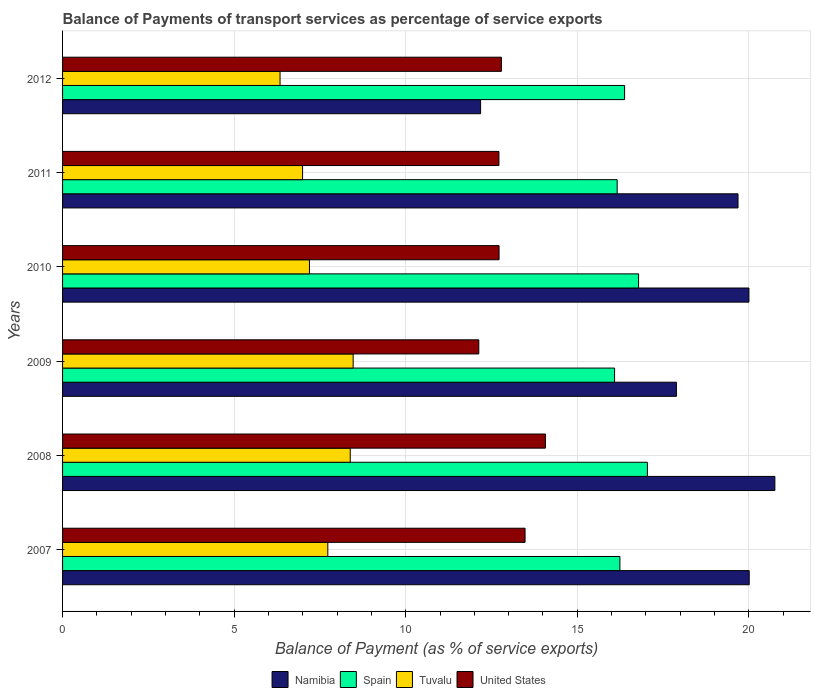Are the number of bars per tick equal to the number of legend labels?
Your response must be concise. Yes. What is the label of the 6th group of bars from the top?
Provide a succinct answer. 2007. What is the balance of payments of transport services in Namibia in 2010?
Give a very brief answer. 20. Across all years, what is the maximum balance of payments of transport services in Namibia?
Your answer should be compact. 20.76. Across all years, what is the minimum balance of payments of transport services in Spain?
Your answer should be compact. 16.09. In which year was the balance of payments of transport services in Spain maximum?
Ensure brevity in your answer.  2008. In which year was the balance of payments of transport services in United States minimum?
Ensure brevity in your answer.  2009. What is the total balance of payments of transport services in Spain in the graph?
Make the answer very short. 98.7. What is the difference between the balance of payments of transport services in Tuvalu in 2010 and that in 2011?
Your response must be concise. 0.2. What is the difference between the balance of payments of transport services in Spain in 2010 and the balance of payments of transport services in United States in 2012?
Your response must be concise. 4. What is the average balance of payments of transport services in Namibia per year?
Keep it short and to the point. 18.42. In the year 2007, what is the difference between the balance of payments of transport services in United States and balance of payments of transport services in Spain?
Your response must be concise. -2.76. In how many years, is the balance of payments of transport services in Spain greater than 4 %?
Offer a terse response. 6. What is the ratio of the balance of payments of transport services in Spain in 2010 to that in 2012?
Provide a short and direct response. 1.02. What is the difference between the highest and the second highest balance of payments of transport services in Namibia?
Ensure brevity in your answer.  0.75. What is the difference between the highest and the lowest balance of payments of transport services in Spain?
Your answer should be very brief. 0.96. In how many years, is the balance of payments of transport services in Tuvalu greater than the average balance of payments of transport services in Tuvalu taken over all years?
Your response must be concise. 3. Is it the case that in every year, the sum of the balance of payments of transport services in United States and balance of payments of transport services in Tuvalu is greater than the sum of balance of payments of transport services in Spain and balance of payments of transport services in Namibia?
Make the answer very short. No. What does the 2nd bar from the bottom in 2010 represents?
Offer a very short reply. Spain. Is it the case that in every year, the sum of the balance of payments of transport services in Tuvalu and balance of payments of transport services in Spain is greater than the balance of payments of transport services in Namibia?
Give a very brief answer. Yes. How many bars are there?
Offer a very short reply. 24. How many years are there in the graph?
Offer a very short reply. 6. Are the values on the major ticks of X-axis written in scientific E-notation?
Your response must be concise. No. Does the graph contain any zero values?
Your answer should be compact. No. Where does the legend appear in the graph?
Offer a very short reply. Bottom center. How many legend labels are there?
Ensure brevity in your answer.  4. How are the legend labels stacked?
Ensure brevity in your answer.  Horizontal. What is the title of the graph?
Provide a short and direct response. Balance of Payments of transport services as percentage of service exports. Does "Vanuatu" appear as one of the legend labels in the graph?
Give a very brief answer. No. What is the label or title of the X-axis?
Keep it short and to the point. Balance of Payment (as % of service exports). What is the Balance of Payment (as % of service exports) in Namibia in 2007?
Provide a succinct answer. 20.01. What is the Balance of Payment (as % of service exports) in Spain in 2007?
Give a very brief answer. 16.24. What is the Balance of Payment (as % of service exports) in Tuvalu in 2007?
Offer a very short reply. 7.73. What is the Balance of Payment (as % of service exports) in United States in 2007?
Your response must be concise. 13.48. What is the Balance of Payment (as % of service exports) of Namibia in 2008?
Give a very brief answer. 20.76. What is the Balance of Payment (as % of service exports) in Spain in 2008?
Ensure brevity in your answer.  17.04. What is the Balance of Payment (as % of service exports) of Tuvalu in 2008?
Keep it short and to the point. 8.38. What is the Balance of Payment (as % of service exports) of United States in 2008?
Offer a terse response. 14.07. What is the Balance of Payment (as % of service exports) in Namibia in 2009?
Your response must be concise. 17.89. What is the Balance of Payment (as % of service exports) of Spain in 2009?
Your answer should be very brief. 16.09. What is the Balance of Payment (as % of service exports) of Tuvalu in 2009?
Keep it short and to the point. 8.47. What is the Balance of Payment (as % of service exports) in United States in 2009?
Your response must be concise. 12.13. What is the Balance of Payment (as % of service exports) in Namibia in 2010?
Your answer should be very brief. 20. What is the Balance of Payment (as % of service exports) of Spain in 2010?
Your response must be concise. 16.79. What is the Balance of Payment (as % of service exports) in Tuvalu in 2010?
Your answer should be compact. 7.19. What is the Balance of Payment (as % of service exports) of United States in 2010?
Provide a short and direct response. 12.72. What is the Balance of Payment (as % of service exports) of Namibia in 2011?
Offer a terse response. 19.68. What is the Balance of Payment (as % of service exports) of Spain in 2011?
Provide a short and direct response. 16.16. What is the Balance of Payment (as % of service exports) of Tuvalu in 2011?
Give a very brief answer. 6.99. What is the Balance of Payment (as % of service exports) of United States in 2011?
Your answer should be compact. 12.72. What is the Balance of Payment (as % of service exports) in Namibia in 2012?
Provide a succinct answer. 12.18. What is the Balance of Payment (as % of service exports) of Spain in 2012?
Your answer should be compact. 16.38. What is the Balance of Payment (as % of service exports) of Tuvalu in 2012?
Provide a short and direct response. 6.34. What is the Balance of Payment (as % of service exports) of United States in 2012?
Your response must be concise. 12.79. Across all years, what is the maximum Balance of Payment (as % of service exports) of Namibia?
Your answer should be compact. 20.76. Across all years, what is the maximum Balance of Payment (as % of service exports) in Spain?
Your response must be concise. 17.04. Across all years, what is the maximum Balance of Payment (as % of service exports) of Tuvalu?
Make the answer very short. 8.47. Across all years, what is the maximum Balance of Payment (as % of service exports) of United States?
Ensure brevity in your answer.  14.07. Across all years, what is the minimum Balance of Payment (as % of service exports) in Namibia?
Your answer should be compact. 12.18. Across all years, what is the minimum Balance of Payment (as % of service exports) of Spain?
Give a very brief answer. 16.09. Across all years, what is the minimum Balance of Payment (as % of service exports) of Tuvalu?
Your answer should be very brief. 6.34. Across all years, what is the minimum Balance of Payment (as % of service exports) in United States?
Your response must be concise. 12.13. What is the total Balance of Payment (as % of service exports) of Namibia in the graph?
Keep it short and to the point. 110.52. What is the total Balance of Payment (as % of service exports) of Spain in the graph?
Give a very brief answer. 98.7. What is the total Balance of Payment (as % of service exports) in Tuvalu in the graph?
Provide a short and direct response. 45.11. What is the total Balance of Payment (as % of service exports) in United States in the graph?
Ensure brevity in your answer.  77.9. What is the difference between the Balance of Payment (as % of service exports) of Namibia in 2007 and that in 2008?
Provide a succinct answer. -0.75. What is the difference between the Balance of Payment (as % of service exports) of Spain in 2007 and that in 2008?
Provide a short and direct response. -0.8. What is the difference between the Balance of Payment (as % of service exports) in Tuvalu in 2007 and that in 2008?
Offer a very short reply. -0.65. What is the difference between the Balance of Payment (as % of service exports) in United States in 2007 and that in 2008?
Ensure brevity in your answer.  -0.59. What is the difference between the Balance of Payment (as % of service exports) of Namibia in 2007 and that in 2009?
Provide a short and direct response. 2.12. What is the difference between the Balance of Payment (as % of service exports) in Spain in 2007 and that in 2009?
Provide a succinct answer. 0.16. What is the difference between the Balance of Payment (as % of service exports) in Tuvalu in 2007 and that in 2009?
Make the answer very short. -0.74. What is the difference between the Balance of Payment (as % of service exports) in United States in 2007 and that in 2009?
Make the answer very short. 1.35. What is the difference between the Balance of Payment (as % of service exports) of Namibia in 2007 and that in 2010?
Provide a succinct answer. 0.01. What is the difference between the Balance of Payment (as % of service exports) of Spain in 2007 and that in 2010?
Offer a terse response. -0.54. What is the difference between the Balance of Payment (as % of service exports) of Tuvalu in 2007 and that in 2010?
Offer a very short reply. 0.54. What is the difference between the Balance of Payment (as % of service exports) of United States in 2007 and that in 2010?
Make the answer very short. 0.76. What is the difference between the Balance of Payment (as % of service exports) of Namibia in 2007 and that in 2011?
Keep it short and to the point. 0.33. What is the difference between the Balance of Payment (as % of service exports) of Spain in 2007 and that in 2011?
Your answer should be very brief. 0.08. What is the difference between the Balance of Payment (as % of service exports) of Tuvalu in 2007 and that in 2011?
Your response must be concise. 0.73. What is the difference between the Balance of Payment (as % of service exports) in United States in 2007 and that in 2011?
Your answer should be compact. 0.76. What is the difference between the Balance of Payment (as % of service exports) of Namibia in 2007 and that in 2012?
Your response must be concise. 7.83. What is the difference between the Balance of Payment (as % of service exports) in Spain in 2007 and that in 2012?
Keep it short and to the point. -0.14. What is the difference between the Balance of Payment (as % of service exports) of Tuvalu in 2007 and that in 2012?
Ensure brevity in your answer.  1.39. What is the difference between the Balance of Payment (as % of service exports) of United States in 2007 and that in 2012?
Provide a succinct answer. 0.69. What is the difference between the Balance of Payment (as % of service exports) in Namibia in 2008 and that in 2009?
Provide a succinct answer. 2.87. What is the difference between the Balance of Payment (as % of service exports) in Spain in 2008 and that in 2009?
Provide a succinct answer. 0.96. What is the difference between the Balance of Payment (as % of service exports) in Tuvalu in 2008 and that in 2009?
Your answer should be very brief. -0.09. What is the difference between the Balance of Payment (as % of service exports) in United States in 2008 and that in 2009?
Offer a terse response. 1.94. What is the difference between the Balance of Payment (as % of service exports) in Namibia in 2008 and that in 2010?
Ensure brevity in your answer.  0.76. What is the difference between the Balance of Payment (as % of service exports) of Spain in 2008 and that in 2010?
Offer a very short reply. 0.26. What is the difference between the Balance of Payment (as % of service exports) of Tuvalu in 2008 and that in 2010?
Provide a short and direct response. 1.19. What is the difference between the Balance of Payment (as % of service exports) of United States in 2008 and that in 2010?
Offer a terse response. 1.35. What is the difference between the Balance of Payment (as % of service exports) in Namibia in 2008 and that in 2011?
Offer a very short reply. 1.07. What is the difference between the Balance of Payment (as % of service exports) in Spain in 2008 and that in 2011?
Make the answer very short. 0.88. What is the difference between the Balance of Payment (as % of service exports) of Tuvalu in 2008 and that in 2011?
Offer a very short reply. 1.39. What is the difference between the Balance of Payment (as % of service exports) of United States in 2008 and that in 2011?
Offer a very short reply. 1.35. What is the difference between the Balance of Payment (as % of service exports) in Namibia in 2008 and that in 2012?
Keep it short and to the point. 8.58. What is the difference between the Balance of Payment (as % of service exports) in Spain in 2008 and that in 2012?
Your answer should be very brief. 0.66. What is the difference between the Balance of Payment (as % of service exports) in Tuvalu in 2008 and that in 2012?
Make the answer very short. 2.05. What is the difference between the Balance of Payment (as % of service exports) in United States in 2008 and that in 2012?
Ensure brevity in your answer.  1.28. What is the difference between the Balance of Payment (as % of service exports) in Namibia in 2009 and that in 2010?
Your response must be concise. -2.11. What is the difference between the Balance of Payment (as % of service exports) in Spain in 2009 and that in 2010?
Provide a short and direct response. -0.7. What is the difference between the Balance of Payment (as % of service exports) in Tuvalu in 2009 and that in 2010?
Keep it short and to the point. 1.27. What is the difference between the Balance of Payment (as % of service exports) in United States in 2009 and that in 2010?
Give a very brief answer. -0.59. What is the difference between the Balance of Payment (as % of service exports) in Namibia in 2009 and that in 2011?
Provide a succinct answer. -1.79. What is the difference between the Balance of Payment (as % of service exports) of Spain in 2009 and that in 2011?
Your answer should be very brief. -0.08. What is the difference between the Balance of Payment (as % of service exports) of Tuvalu in 2009 and that in 2011?
Provide a short and direct response. 1.47. What is the difference between the Balance of Payment (as % of service exports) in United States in 2009 and that in 2011?
Your answer should be very brief. -0.59. What is the difference between the Balance of Payment (as % of service exports) of Namibia in 2009 and that in 2012?
Offer a very short reply. 5.71. What is the difference between the Balance of Payment (as % of service exports) of Spain in 2009 and that in 2012?
Your response must be concise. -0.29. What is the difference between the Balance of Payment (as % of service exports) of Tuvalu in 2009 and that in 2012?
Offer a very short reply. 2.13. What is the difference between the Balance of Payment (as % of service exports) of United States in 2009 and that in 2012?
Give a very brief answer. -0.66. What is the difference between the Balance of Payment (as % of service exports) of Namibia in 2010 and that in 2011?
Your response must be concise. 0.32. What is the difference between the Balance of Payment (as % of service exports) in Spain in 2010 and that in 2011?
Your answer should be very brief. 0.62. What is the difference between the Balance of Payment (as % of service exports) in United States in 2010 and that in 2011?
Keep it short and to the point. 0. What is the difference between the Balance of Payment (as % of service exports) in Namibia in 2010 and that in 2012?
Offer a terse response. 7.82. What is the difference between the Balance of Payment (as % of service exports) of Spain in 2010 and that in 2012?
Your response must be concise. 0.41. What is the difference between the Balance of Payment (as % of service exports) in Tuvalu in 2010 and that in 2012?
Make the answer very short. 0.86. What is the difference between the Balance of Payment (as % of service exports) in United States in 2010 and that in 2012?
Offer a very short reply. -0.07. What is the difference between the Balance of Payment (as % of service exports) of Namibia in 2011 and that in 2012?
Make the answer very short. 7.5. What is the difference between the Balance of Payment (as % of service exports) of Spain in 2011 and that in 2012?
Your answer should be very brief. -0.22. What is the difference between the Balance of Payment (as % of service exports) of Tuvalu in 2011 and that in 2012?
Offer a terse response. 0.66. What is the difference between the Balance of Payment (as % of service exports) in United States in 2011 and that in 2012?
Give a very brief answer. -0.07. What is the difference between the Balance of Payment (as % of service exports) in Namibia in 2007 and the Balance of Payment (as % of service exports) in Spain in 2008?
Provide a succinct answer. 2.97. What is the difference between the Balance of Payment (as % of service exports) in Namibia in 2007 and the Balance of Payment (as % of service exports) in Tuvalu in 2008?
Your answer should be compact. 11.63. What is the difference between the Balance of Payment (as % of service exports) of Namibia in 2007 and the Balance of Payment (as % of service exports) of United States in 2008?
Give a very brief answer. 5.94. What is the difference between the Balance of Payment (as % of service exports) of Spain in 2007 and the Balance of Payment (as % of service exports) of Tuvalu in 2008?
Give a very brief answer. 7.86. What is the difference between the Balance of Payment (as % of service exports) of Spain in 2007 and the Balance of Payment (as % of service exports) of United States in 2008?
Ensure brevity in your answer.  2.17. What is the difference between the Balance of Payment (as % of service exports) of Tuvalu in 2007 and the Balance of Payment (as % of service exports) of United States in 2008?
Your response must be concise. -6.34. What is the difference between the Balance of Payment (as % of service exports) of Namibia in 2007 and the Balance of Payment (as % of service exports) of Spain in 2009?
Your response must be concise. 3.92. What is the difference between the Balance of Payment (as % of service exports) of Namibia in 2007 and the Balance of Payment (as % of service exports) of Tuvalu in 2009?
Your answer should be compact. 11.54. What is the difference between the Balance of Payment (as % of service exports) in Namibia in 2007 and the Balance of Payment (as % of service exports) in United States in 2009?
Ensure brevity in your answer.  7.88. What is the difference between the Balance of Payment (as % of service exports) in Spain in 2007 and the Balance of Payment (as % of service exports) in Tuvalu in 2009?
Give a very brief answer. 7.77. What is the difference between the Balance of Payment (as % of service exports) in Spain in 2007 and the Balance of Payment (as % of service exports) in United States in 2009?
Your answer should be compact. 4.11. What is the difference between the Balance of Payment (as % of service exports) of Namibia in 2007 and the Balance of Payment (as % of service exports) of Spain in 2010?
Provide a succinct answer. 3.22. What is the difference between the Balance of Payment (as % of service exports) of Namibia in 2007 and the Balance of Payment (as % of service exports) of Tuvalu in 2010?
Offer a terse response. 12.82. What is the difference between the Balance of Payment (as % of service exports) of Namibia in 2007 and the Balance of Payment (as % of service exports) of United States in 2010?
Provide a short and direct response. 7.29. What is the difference between the Balance of Payment (as % of service exports) in Spain in 2007 and the Balance of Payment (as % of service exports) in Tuvalu in 2010?
Keep it short and to the point. 9.05. What is the difference between the Balance of Payment (as % of service exports) of Spain in 2007 and the Balance of Payment (as % of service exports) of United States in 2010?
Give a very brief answer. 3.52. What is the difference between the Balance of Payment (as % of service exports) in Tuvalu in 2007 and the Balance of Payment (as % of service exports) in United States in 2010?
Offer a terse response. -4.99. What is the difference between the Balance of Payment (as % of service exports) of Namibia in 2007 and the Balance of Payment (as % of service exports) of Spain in 2011?
Ensure brevity in your answer.  3.85. What is the difference between the Balance of Payment (as % of service exports) in Namibia in 2007 and the Balance of Payment (as % of service exports) in Tuvalu in 2011?
Provide a short and direct response. 13.02. What is the difference between the Balance of Payment (as % of service exports) in Namibia in 2007 and the Balance of Payment (as % of service exports) in United States in 2011?
Your answer should be compact. 7.29. What is the difference between the Balance of Payment (as % of service exports) of Spain in 2007 and the Balance of Payment (as % of service exports) of Tuvalu in 2011?
Make the answer very short. 9.25. What is the difference between the Balance of Payment (as % of service exports) in Spain in 2007 and the Balance of Payment (as % of service exports) in United States in 2011?
Make the answer very short. 3.53. What is the difference between the Balance of Payment (as % of service exports) of Tuvalu in 2007 and the Balance of Payment (as % of service exports) of United States in 2011?
Your response must be concise. -4.99. What is the difference between the Balance of Payment (as % of service exports) of Namibia in 2007 and the Balance of Payment (as % of service exports) of Spain in 2012?
Ensure brevity in your answer.  3.63. What is the difference between the Balance of Payment (as % of service exports) in Namibia in 2007 and the Balance of Payment (as % of service exports) in Tuvalu in 2012?
Your answer should be very brief. 13.67. What is the difference between the Balance of Payment (as % of service exports) in Namibia in 2007 and the Balance of Payment (as % of service exports) in United States in 2012?
Your answer should be compact. 7.22. What is the difference between the Balance of Payment (as % of service exports) in Spain in 2007 and the Balance of Payment (as % of service exports) in Tuvalu in 2012?
Make the answer very short. 9.9. What is the difference between the Balance of Payment (as % of service exports) of Spain in 2007 and the Balance of Payment (as % of service exports) of United States in 2012?
Your answer should be very brief. 3.45. What is the difference between the Balance of Payment (as % of service exports) in Tuvalu in 2007 and the Balance of Payment (as % of service exports) in United States in 2012?
Keep it short and to the point. -5.06. What is the difference between the Balance of Payment (as % of service exports) in Namibia in 2008 and the Balance of Payment (as % of service exports) in Spain in 2009?
Ensure brevity in your answer.  4.67. What is the difference between the Balance of Payment (as % of service exports) of Namibia in 2008 and the Balance of Payment (as % of service exports) of Tuvalu in 2009?
Offer a terse response. 12.29. What is the difference between the Balance of Payment (as % of service exports) of Namibia in 2008 and the Balance of Payment (as % of service exports) of United States in 2009?
Offer a very short reply. 8.63. What is the difference between the Balance of Payment (as % of service exports) in Spain in 2008 and the Balance of Payment (as % of service exports) in Tuvalu in 2009?
Provide a short and direct response. 8.57. What is the difference between the Balance of Payment (as % of service exports) of Spain in 2008 and the Balance of Payment (as % of service exports) of United States in 2009?
Keep it short and to the point. 4.91. What is the difference between the Balance of Payment (as % of service exports) of Tuvalu in 2008 and the Balance of Payment (as % of service exports) of United States in 2009?
Offer a very short reply. -3.75. What is the difference between the Balance of Payment (as % of service exports) of Namibia in 2008 and the Balance of Payment (as % of service exports) of Spain in 2010?
Your response must be concise. 3.97. What is the difference between the Balance of Payment (as % of service exports) in Namibia in 2008 and the Balance of Payment (as % of service exports) in Tuvalu in 2010?
Your answer should be very brief. 13.56. What is the difference between the Balance of Payment (as % of service exports) of Namibia in 2008 and the Balance of Payment (as % of service exports) of United States in 2010?
Provide a succinct answer. 8.04. What is the difference between the Balance of Payment (as % of service exports) of Spain in 2008 and the Balance of Payment (as % of service exports) of Tuvalu in 2010?
Give a very brief answer. 9.85. What is the difference between the Balance of Payment (as % of service exports) in Spain in 2008 and the Balance of Payment (as % of service exports) in United States in 2010?
Provide a succinct answer. 4.32. What is the difference between the Balance of Payment (as % of service exports) in Tuvalu in 2008 and the Balance of Payment (as % of service exports) in United States in 2010?
Give a very brief answer. -4.34. What is the difference between the Balance of Payment (as % of service exports) in Namibia in 2008 and the Balance of Payment (as % of service exports) in Spain in 2011?
Ensure brevity in your answer.  4.6. What is the difference between the Balance of Payment (as % of service exports) of Namibia in 2008 and the Balance of Payment (as % of service exports) of Tuvalu in 2011?
Make the answer very short. 13.76. What is the difference between the Balance of Payment (as % of service exports) of Namibia in 2008 and the Balance of Payment (as % of service exports) of United States in 2011?
Provide a short and direct response. 8.04. What is the difference between the Balance of Payment (as % of service exports) of Spain in 2008 and the Balance of Payment (as % of service exports) of Tuvalu in 2011?
Make the answer very short. 10.05. What is the difference between the Balance of Payment (as % of service exports) in Spain in 2008 and the Balance of Payment (as % of service exports) in United States in 2011?
Make the answer very short. 4.33. What is the difference between the Balance of Payment (as % of service exports) of Tuvalu in 2008 and the Balance of Payment (as % of service exports) of United States in 2011?
Make the answer very short. -4.33. What is the difference between the Balance of Payment (as % of service exports) of Namibia in 2008 and the Balance of Payment (as % of service exports) of Spain in 2012?
Offer a terse response. 4.38. What is the difference between the Balance of Payment (as % of service exports) of Namibia in 2008 and the Balance of Payment (as % of service exports) of Tuvalu in 2012?
Make the answer very short. 14.42. What is the difference between the Balance of Payment (as % of service exports) in Namibia in 2008 and the Balance of Payment (as % of service exports) in United States in 2012?
Ensure brevity in your answer.  7.97. What is the difference between the Balance of Payment (as % of service exports) of Spain in 2008 and the Balance of Payment (as % of service exports) of Tuvalu in 2012?
Your answer should be compact. 10.71. What is the difference between the Balance of Payment (as % of service exports) in Spain in 2008 and the Balance of Payment (as % of service exports) in United States in 2012?
Your response must be concise. 4.25. What is the difference between the Balance of Payment (as % of service exports) of Tuvalu in 2008 and the Balance of Payment (as % of service exports) of United States in 2012?
Offer a very short reply. -4.41. What is the difference between the Balance of Payment (as % of service exports) in Namibia in 2009 and the Balance of Payment (as % of service exports) in Spain in 2010?
Give a very brief answer. 1.1. What is the difference between the Balance of Payment (as % of service exports) of Namibia in 2009 and the Balance of Payment (as % of service exports) of Tuvalu in 2010?
Keep it short and to the point. 10.69. What is the difference between the Balance of Payment (as % of service exports) of Namibia in 2009 and the Balance of Payment (as % of service exports) of United States in 2010?
Give a very brief answer. 5.17. What is the difference between the Balance of Payment (as % of service exports) of Spain in 2009 and the Balance of Payment (as % of service exports) of Tuvalu in 2010?
Give a very brief answer. 8.89. What is the difference between the Balance of Payment (as % of service exports) of Spain in 2009 and the Balance of Payment (as % of service exports) of United States in 2010?
Provide a succinct answer. 3.37. What is the difference between the Balance of Payment (as % of service exports) of Tuvalu in 2009 and the Balance of Payment (as % of service exports) of United States in 2010?
Offer a terse response. -4.25. What is the difference between the Balance of Payment (as % of service exports) of Namibia in 2009 and the Balance of Payment (as % of service exports) of Spain in 2011?
Your response must be concise. 1.73. What is the difference between the Balance of Payment (as % of service exports) of Namibia in 2009 and the Balance of Payment (as % of service exports) of Tuvalu in 2011?
Make the answer very short. 10.89. What is the difference between the Balance of Payment (as % of service exports) in Namibia in 2009 and the Balance of Payment (as % of service exports) in United States in 2011?
Keep it short and to the point. 5.17. What is the difference between the Balance of Payment (as % of service exports) of Spain in 2009 and the Balance of Payment (as % of service exports) of Tuvalu in 2011?
Make the answer very short. 9.09. What is the difference between the Balance of Payment (as % of service exports) of Spain in 2009 and the Balance of Payment (as % of service exports) of United States in 2011?
Your response must be concise. 3.37. What is the difference between the Balance of Payment (as % of service exports) in Tuvalu in 2009 and the Balance of Payment (as % of service exports) in United States in 2011?
Your answer should be very brief. -4.25. What is the difference between the Balance of Payment (as % of service exports) of Namibia in 2009 and the Balance of Payment (as % of service exports) of Spain in 2012?
Your answer should be compact. 1.51. What is the difference between the Balance of Payment (as % of service exports) of Namibia in 2009 and the Balance of Payment (as % of service exports) of Tuvalu in 2012?
Provide a short and direct response. 11.55. What is the difference between the Balance of Payment (as % of service exports) of Namibia in 2009 and the Balance of Payment (as % of service exports) of United States in 2012?
Your answer should be compact. 5.1. What is the difference between the Balance of Payment (as % of service exports) of Spain in 2009 and the Balance of Payment (as % of service exports) of Tuvalu in 2012?
Provide a succinct answer. 9.75. What is the difference between the Balance of Payment (as % of service exports) of Spain in 2009 and the Balance of Payment (as % of service exports) of United States in 2012?
Provide a succinct answer. 3.3. What is the difference between the Balance of Payment (as % of service exports) in Tuvalu in 2009 and the Balance of Payment (as % of service exports) in United States in 2012?
Make the answer very short. -4.32. What is the difference between the Balance of Payment (as % of service exports) of Namibia in 2010 and the Balance of Payment (as % of service exports) of Spain in 2011?
Offer a very short reply. 3.84. What is the difference between the Balance of Payment (as % of service exports) in Namibia in 2010 and the Balance of Payment (as % of service exports) in Tuvalu in 2011?
Ensure brevity in your answer.  13.01. What is the difference between the Balance of Payment (as % of service exports) of Namibia in 2010 and the Balance of Payment (as % of service exports) of United States in 2011?
Give a very brief answer. 7.29. What is the difference between the Balance of Payment (as % of service exports) of Spain in 2010 and the Balance of Payment (as % of service exports) of Tuvalu in 2011?
Provide a short and direct response. 9.79. What is the difference between the Balance of Payment (as % of service exports) of Spain in 2010 and the Balance of Payment (as % of service exports) of United States in 2011?
Give a very brief answer. 4.07. What is the difference between the Balance of Payment (as % of service exports) of Tuvalu in 2010 and the Balance of Payment (as % of service exports) of United States in 2011?
Give a very brief answer. -5.52. What is the difference between the Balance of Payment (as % of service exports) in Namibia in 2010 and the Balance of Payment (as % of service exports) in Spain in 2012?
Offer a terse response. 3.62. What is the difference between the Balance of Payment (as % of service exports) of Namibia in 2010 and the Balance of Payment (as % of service exports) of Tuvalu in 2012?
Keep it short and to the point. 13.66. What is the difference between the Balance of Payment (as % of service exports) of Namibia in 2010 and the Balance of Payment (as % of service exports) of United States in 2012?
Your response must be concise. 7.21. What is the difference between the Balance of Payment (as % of service exports) of Spain in 2010 and the Balance of Payment (as % of service exports) of Tuvalu in 2012?
Offer a very short reply. 10.45. What is the difference between the Balance of Payment (as % of service exports) of Spain in 2010 and the Balance of Payment (as % of service exports) of United States in 2012?
Provide a short and direct response. 4. What is the difference between the Balance of Payment (as % of service exports) in Tuvalu in 2010 and the Balance of Payment (as % of service exports) in United States in 2012?
Give a very brief answer. -5.59. What is the difference between the Balance of Payment (as % of service exports) in Namibia in 2011 and the Balance of Payment (as % of service exports) in Spain in 2012?
Offer a terse response. 3.31. What is the difference between the Balance of Payment (as % of service exports) of Namibia in 2011 and the Balance of Payment (as % of service exports) of Tuvalu in 2012?
Make the answer very short. 13.35. What is the difference between the Balance of Payment (as % of service exports) of Namibia in 2011 and the Balance of Payment (as % of service exports) of United States in 2012?
Give a very brief answer. 6.9. What is the difference between the Balance of Payment (as % of service exports) in Spain in 2011 and the Balance of Payment (as % of service exports) in Tuvalu in 2012?
Your response must be concise. 9.82. What is the difference between the Balance of Payment (as % of service exports) of Spain in 2011 and the Balance of Payment (as % of service exports) of United States in 2012?
Provide a succinct answer. 3.37. What is the difference between the Balance of Payment (as % of service exports) of Tuvalu in 2011 and the Balance of Payment (as % of service exports) of United States in 2012?
Make the answer very short. -5.79. What is the average Balance of Payment (as % of service exports) of Namibia per year?
Provide a short and direct response. 18.42. What is the average Balance of Payment (as % of service exports) of Spain per year?
Ensure brevity in your answer.  16.45. What is the average Balance of Payment (as % of service exports) in Tuvalu per year?
Offer a terse response. 7.52. What is the average Balance of Payment (as % of service exports) in United States per year?
Ensure brevity in your answer.  12.98. In the year 2007, what is the difference between the Balance of Payment (as % of service exports) of Namibia and Balance of Payment (as % of service exports) of Spain?
Your response must be concise. 3.77. In the year 2007, what is the difference between the Balance of Payment (as % of service exports) in Namibia and Balance of Payment (as % of service exports) in Tuvalu?
Keep it short and to the point. 12.28. In the year 2007, what is the difference between the Balance of Payment (as % of service exports) in Namibia and Balance of Payment (as % of service exports) in United States?
Your answer should be very brief. 6.53. In the year 2007, what is the difference between the Balance of Payment (as % of service exports) in Spain and Balance of Payment (as % of service exports) in Tuvalu?
Your answer should be very brief. 8.51. In the year 2007, what is the difference between the Balance of Payment (as % of service exports) of Spain and Balance of Payment (as % of service exports) of United States?
Give a very brief answer. 2.76. In the year 2007, what is the difference between the Balance of Payment (as % of service exports) of Tuvalu and Balance of Payment (as % of service exports) of United States?
Make the answer very short. -5.75. In the year 2008, what is the difference between the Balance of Payment (as % of service exports) of Namibia and Balance of Payment (as % of service exports) of Spain?
Offer a very short reply. 3.71. In the year 2008, what is the difference between the Balance of Payment (as % of service exports) in Namibia and Balance of Payment (as % of service exports) in Tuvalu?
Your answer should be compact. 12.37. In the year 2008, what is the difference between the Balance of Payment (as % of service exports) in Namibia and Balance of Payment (as % of service exports) in United States?
Provide a succinct answer. 6.69. In the year 2008, what is the difference between the Balance of Payment (as % of service exports) of Spain and Balance of Payment (as % of service exports) of Tuvalu?
Provide a short and direct response. 8.66. In the year 2008, what is the difference between the Balance of Payment (as % of service exports) of Spain and Balance of Payment (as % of service exports) of United States?
Keep it short and to the point. 2.97. In the year 2008, what is the difference between the Balance of Payment (as % of service exports) in Tuvalu and Balance of Payment (as % of service exports) in United States?
Offer a very short reply. -5.69. In the year 2009, what is the difference between the Balance of Payment (as % of service exports) of Namibia and Balance of Payment (as % of service exports) of Spain?
Keep it short and to the point. 1.8. In the year 2009, what is the difference between the Balance of Payment (as % of service exports) in Namibia and Balance of Payment (as % of service exports) in Tuvalu?
Your answer should be compact. 9.42. In the year 2009, what is the difference between the Balance of Payment (as % of service exports) in Namibia and Balance of Payment (as % of service exports) in United States?
Keep it short and to the point. 5.76. In the year 2009, what is the difference between the Balance of Payment (as % of service exports) of Spain and Balance of Payment (as % of service exports) of Tuvalu?
Provide a succinct answer. 7.62. In the year 2009, what is the difference between the Balance of Payment (as % of service exports) in Spain and Balance of Payment (as % of service exports) in United States?
Provide a short and direct response. 3.96. In the year 2009, what is the difference between the Balance of Payment (as % of service exports) in Tuvalu and Balance of Payment (as % of service exports) in United States?
Provide a short and direct response. -3.66. In the year 2010, what is the difference between the Balance of Payment (as % of service exports) in Namibia and Balance of Payment (as % of service exports) in Spain?
Offer a terse response. 3.22. In the year 2010, what is the difference between the Balance of Payment (as % of service exports) of Namibia and Balance of Payment (as % of service exports) of Tuvalu?
Your response must be concise. 12.81. In the year 2010, what is the difference between the Balance of Payment (as % of service exports) of Namibia and Balance of Payment (as % of service exports) of United States?
Your response must be concise. 7.28. In the year 2010, what is the difference between the Balance of Payment (as % of service exports) in Spain and Balance of Payment (as % of service exports) in Tuvalu?
Your answer should be very brief. 9.59. In the year 2010, what is the difference between the Balance of Payment (as % of service exports) in Spain and Balance of Payment (as % of service exports) in United States?
Make the answer very short. 4.07. In the year 2010, what is the difference between the Balance of Payment (as % of service exports) in Tuvalu and Balance of Payment (as % of service exports) in United States?
Offer a terse response. -5.53. In the year 2011, what is the difference between the Balance of Payment (as % of service exports) of Namibia and Balance of Payment (as % of service exports) of Spain?
Your response must be concise. 3.52. In the year 2011, what is the difference between the Balance of Payment (as % of service exports) of Namibia and Balance of Payment (as % of service exports) of Tuvalu?
Provide a succinct answer. 12.69. In the year 2011, what is the difference between the Balance of Payment (as % of service exports) in Namibia and Balance of Payment (as % of service exports) in United States?
Offer a very short reply. 6.97. In the year 2011, what is the difference between the Balance of Payment (as % of service exports) in Spain and Balance of Payment (as % of service exports) in Tuvalu?
Make the answer very short. 9.17. In the year 2011, what is the difference between the Balance of Payment (as % of service exports) of Spain and Balance of Payment (as % of service exports) of United States?
Provide a short and direct response. 3.45. In the year 2011, what is the difference between the Balance of Payment (as % of service exports) of Tuvalu and Balance of Payment (as % of service exports) of United States?
Your answer should be very brief. -5.72. In the year 2012, what is the difference between the Balance of Payment (as % of service exports) in Namibia and Balance of Payment (as % of service exports) in Spain?
Ensure brevity in your answer.  -4.2. In the year 2012, what is the difference between the Balance of Payment (as % of service exports) in Namibia and Balance of Payment (as % of service exports) in Tuvalu?
Your response must be concise. 5.84. In the year 2012, what is the difference between the Balance of Payment (as % of service exports) of Namibia and Balance of Payment (as % of service exports) of United States?
Offer a terse response. -0.61. In the year 2012, what is the difference between the Balance of Payment (as % of service exports) in Spain and Balance of Payment (as % of service exports) in Tuvalu?
Provide a succinct answer. 10.04. In the year 2012, what is the difference between the Balance of Payment (as % of service exports) of Spain and Balance of Payment (as % of service exports) of United States?
Your response must be concise. 3.59. In the year 2012, what is the difference between the Balance of Payment (as % of service exports) in Tuvalu and Balance of Payment (as % of service exports) in United States?
Provide a succinct answer. -6.45. What is the ratio of the Balance of Payment (as % of service exports) of Namibia in 2007 to that in 2008?
Offer a very short reply. 0.96. What is the ratio of the Balance of Payment (as % of service exports) of Spain in 2007 to that in 2008?
Your answer should be compact. 0.95. What is the ratio of the Balance of Payment (as % of service exports) of Tuvalu in 2007 to that in 2008?
Offer a very short reply. 0.92. What is the ratio of the Balance of Payment (as % of service exports) in United States in 2007 to that in 2008?
Give a very brief answer. 0.96. What is the ratio of the Balance of Payment (as % of service exports) of Namibia in 2007 to that in 2009?
Make the answer very short. 1.12. What is the ratio of the Balance of Payment (as % of service exports) of Spain in 2007 to that in 2009?
Offer a terse response. 1.01. What is the ratio of the Balance of Payment (as % of service exports) of Tuvalu in 2007 to that in 2009?
Your answer should be very brief. 0.91. What is the ratio of the Balance of Payment (as % of service exports) in Spain in 2007 to that in 2010?
Ensure brevity in your answer.  0.97. What is the ratio of the Balance of Payment (as % of service exports) of Tuvalu in 2007 to that in 2010?
Your answer should be compact. 1.07. What is the ratio of the Balance of Payment (as % of service exports) of United States in 2007 to that in 2010?
Provide a short and direct response. 1.06. What is the ratio of the Balance of Payment (as % of service exports) in Namibia in 2007 to that in 2011?
Provide a succinct answer. 1.02. What is the ratio of the Balance of Payment (as % of service exports) in Spain in 2007 to that in 2011?
Provide a succinct answer. 1. What is the ratio of the Balance of Payment (as % of service exports) of Tuvalu in 2007 to that in 2011?
Offer a terse response. 1.11. What is the ratio of the Balance of Payment (as % of service exports) of United States in 2007 to that in 2011?
Ensure brevity in your answer.  1.06. What is the ratio of the Balance of Payment (as % of service exports) in Namibia in 2007 to that in 2012?
Offer a terse response. 1.64. What is the ratio of the Balance of Payment (as % of service exports) in Spain in 2007 to that in 2012?
Give a very brief answer. 0.99. What is the ratio of the Balance of Payment (as % of service exports) of Tuvalu in 2007 to that in 2012?
Ensure brevity in your answer.  1.22. What is the ratio of the Balance of Payment (as % of service exports) of United States in 2007 to that in 2012?
Ensure brevity in your answer.  1.05. What is the ratio of the Balance of Payment (as % of service exports) in Namibia in 2008 to that in 2009?
Ensure brevity in your answer.  1.16. What is the ratio of the Balance of Payment (as % of service exports) of Spain in 2008 to that in 2009?
Your answer should be very brief. 1.06. What is the ratio of the Balance of Payment (as % of service exports) of United States in 2008 to that in 2009?
Your response must be concise. 1.16. What is the ratio of the Balance of Payment (as % of service exports) of Namibia in 2008 to that in 2010?
Provide a succinct answer. 1.04. What is the ratio of the Balance of Payment (as % of service exports) of Spain in 2008 to that in 2010?
Give a very brief answer. 1.02. What is the ratio of the Balance of Payment (as % of service exports) in Tuvalu in 2008 to that in 2010?
Keep it short and to the point. 1.17. What is the ratio of the Balance of Payment (as % of service exports) of United States in 2008 to that in 2010?
Your answer should be compact. 1.11. What is the ratio of the Balance of Payment (as % of service exports) in Namibia in 2008 to that in 2011?
Your answer should be very brief. 1.05. What is the ratio of the Balance of Payment (as % of service exports) of Spain in 2008 to that in 2011?
Provide a short and direct response. 1.05. What is the ratio of the Balance of Payment (as % of service exports) in Tuvalu in 2008 to that in 2011?
Provide a short and direct response. 1.2. What is the ratio of the Balance of Payment (as % of service exports) of United States in 2008 to that in 2011?
Offer a very short reply. 1.11. What is the ratio of the Balance of Payment (as % of service exports) of Namibia in 2008 to that in 2012?
Give a very brief answer. 1.7. What is the ratio of the Balance of Payment (as % of service exports) of Spain in 2008 to that in 2012?
Provide a short and direct response. 1.04. What is the ratio of the Balance of Payment (as % of service exports) of Tuvalu in 2008 to that in 2012?
Your answer should be compact. 1.32. What is the ratio of the Balance of Payment (as % of service exports) of United States in 2008 to that in 2012?
Offer a very short reply. 1.1. What is the ratio of the Balance of Payment (as % of service exports) in Namibia in 2009 to that in 2010?
Provide a short and direct response. 0.89. What is the ratio of the Balance of Payment (as % of service exports) of Spain in 2009 to that in 2010?
Offer a very short reply. 0.96. What is the ratio of the Balance of Payment (as % of service exports) of Tuvalu in 2009 to that in 2010?
Offer a terse response. 1.18. What is the ratio of the Balance of Payment (as % of service exports) of United States in 2009 to that in 2010?
Ensure brevity in your answer.  0.95. What is the ratio of the Balance of Payment (as % of service exports) in Namibia in 2009 to that in 2011?
Offer a very short reply. 0.91. What is the ratio of the Balance of Payment (as % of service exports) in Tuvalu in 2009 to that in 2011?
Your answer should be very brief. 1.21. What is the ratio of the Balance of Payment (as % of service exports) in United States in 2009 to that in 2011?
Your answer should be very brief. 0.95. What is the ratio of the Balance of Payment (as % of service exports) of Namibia in 2009 to that in 2012?
Provide a short and direct response. 1.47. What is the ratio of the Balance of Payment (as % of service exports) in Spain in 2009 to that in 2012?
Your answer should be compact. 0.98. What is the ratio of the Balance of Payment (as % of service exports) of Tuvalu in 2009 to that in 2012?
Provide a succinct answer. 1.34. What is the ratio of the Balance of Payment (as % of service exports) in United States in 2009 to that in 2012?
Offer a terse response. 0.95. What is the ratio of the Balance of Payment (as % of service exports) in Namibia in 2010 to that in 2011?
Your response must be concise. 1.02. What is the ratio of the Balance of Payment (as % of service exports) of Spain in 2010 to that in 2011?
Offer a very short reply. 1.04. What is the ratio of the Balance of Payment (as % of service exports) in Tuvalu in 2010 to that in 2011?
Offer a terse response. 1.03. What is the ratio of the Balance of Payment (as % of service exports) in Namibia in 2010 to that in 2012?
Offer a very short reply. 1.64. What is the ratio of the Balance of Payment (as % of service exports) of Spain in 2010 to that in 2012?
Keep it short and to the point. 1.02. What is the ratio of the Balance of Payment (as % of service exports) of Tuvalu in 2010 to that in 2012?
Your answer should be compact. 1.14. What is the ratio of the Balance of Payment (as % of service exports) in United States in 2010 to that in 2012?
Offer a terse response. 0.99. What is the ratio of the Balance of Payment (as % of service exports) in Namibia in 2011 to that in 2012?
Give a very brief answer. 1.62. What is the ratio of the Balance of Payment (as % of service exports) of Tuvalu in 2011 to that in 2012?
Keep it short and to the point. 1.1. What is the difference between the highest and the second highest Balance of Payment (as % of service exports) in Namibia?
Keep it short and to the point. 0.75. What is the difference between the highest and the second highest Balance of Payment (as % of service exports) of Spain?
Your response must be concise. 0.26. What is the difference between the highest and the second highest Balance of Payment (as % of service exports) in Tuvalu?
Offer a terse response. 0.09. What is the difference between the highest and the second highest Balance of Payment (as % of service exports) in United States?
Your response must be concise. 0.59. What is the difference between the highest and the lowest Balance of Payment (as % of service exports) in Namibia?
Your answer should be compact. 8.58. What is the difference between the highest and the lowest Balance of Payment (as % of service exports) in Spain?
Provide a succinct answer. 0.96. What is the difference between the highest and the lowest Balance of Payment (as % of service exports) of Tuvalu?
Ensure brevity in your answer.  2.13. What is the difference between the highest and the lowest Balance of Payment (as % of service exports) in United States?
Keep it short and to the point. 1.94. 